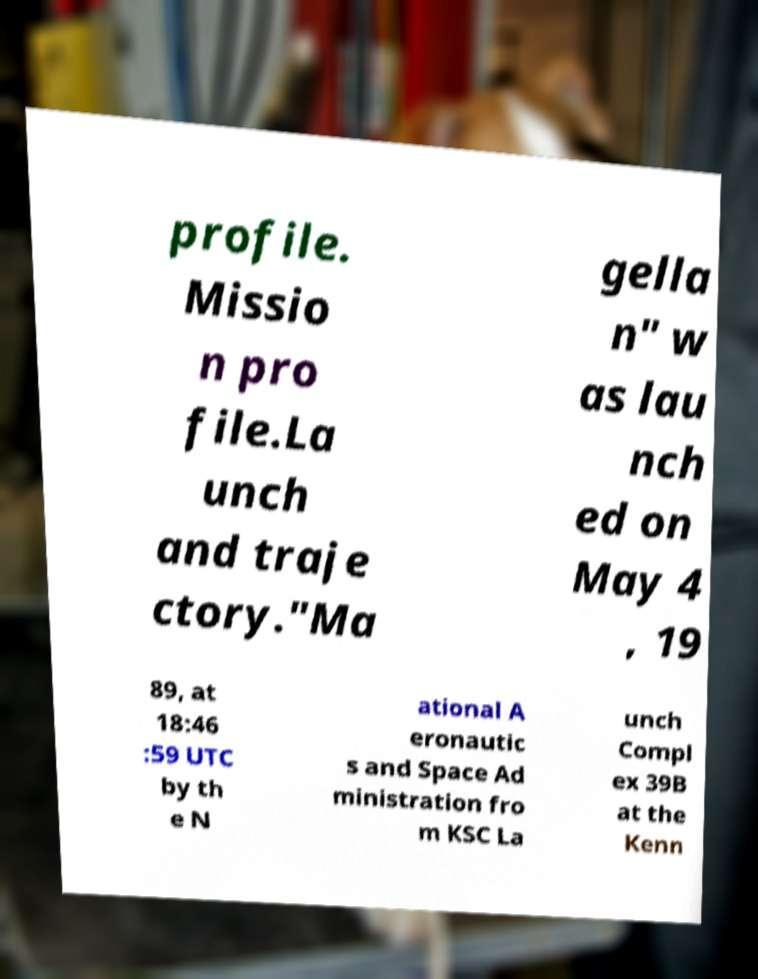Please read and relay the text visible in this image. What does it say? profile. Missio n pro file.La unch and traje ctory."Ma gella n" w as lau nch ed on May 4 , 19 89, at 18:46 :59 UTC by th e N ational A eronautic s and Space Ad ministration fro m KSC La unch Compl ex 39B at the Kenn 